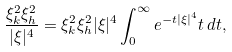<formula> <loc_0><loc_0><loc_500><loc_500>\frac { \xi _ { k } ^ { 2 } \xi _ { h } ^ { 2 } } { | \xi | ^ { 4 } } = \xi _ { k } ^ { 2 } \xi _ { h } ^ { 2 } | \xi | ^ { 4 } \int _ { 0 } ^ { \infty } e ^ { - t | \xi | ^ { 4 } } t \, d t ,</formula> 